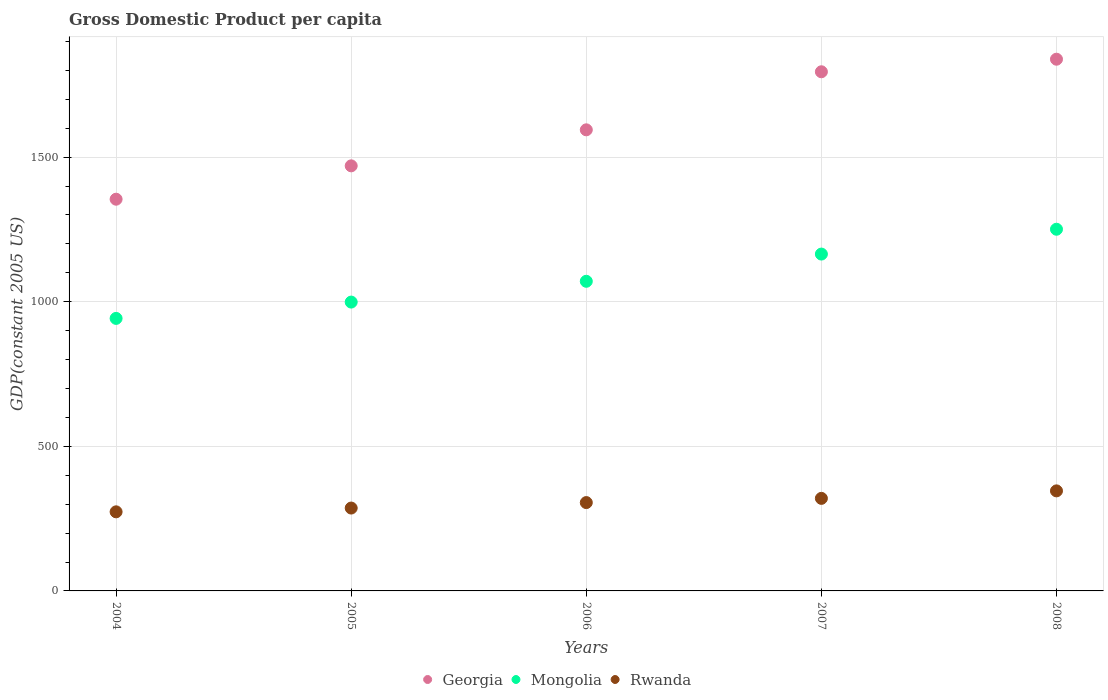Is the number of dotlines equal to the number of legend labels?
Give a very brief answer. Yes. What is the GDP per capita in Rwanda in 2004?
Your answer should be very brief. 273.48. Across all years, what is the maximum GDP per capita in Rwanda?
Provide a succinct answer. 345.97. Across all years, what is the minimum GDP per capita in Georgia?
Provide a short and direct response. 1354.56. What is the total GDP per capita in Georgia in the graph?
Your answer should be compact. 8052.87. What is the difference between the GDP per capita in Rwanda in 2004 and that in 2008?
Keep it short and to the point. -72.48. What is the difference between the GDP per capita in Mongolia in 2006 and the GDP per capita in Rwanda in 2004?
Offer a very short reply. 797.22. What is the average GDP per capita in Rwanda per year?
Your response must be concise. 306.31. In the year 2007, what is the difference between the GDP per capita in Georgia and GDP per capita in Mongolia?
Provide a short and direct response. 630.39. What is the ratio of the GDP per capita in Mongolia in 2007 to that in 2008?
Make the answer very short. 0.93. What is the difference between the highest and the second highest GDP per capita in Georgia?
Your answer should be very brief. 43.47. What is the difference between the highest and the lowest GDP per capita in Georgia?
Make the answer very short. 484.12. In how many years, is the GDP per capita in Rwanda greater than the average GDP per capita in Rwanda taken over all years?
Ensure brevity in your answer.  2. Is the GDP per capita in Mongolia strictly greater than the GDP per capita in Rwanda over the years?
Provide a succinct answer. Yes. Is the GDP per capita in Rwanda strictly less than the GDP per capita in Georgia over the years?
Ensure brevity in your answer.  Yes. How many years are there in the graph?
Your response must be concise. 5. What is the difference between two consecutive major ticks on the Y-axis?
Your answer should be compact. 500. Where does the legend appear in the graph?
Offer a very short reply. Bottom center. How many legend labels are there?
Offer a very short reply. 3. How are the legend labels stacked?
Your answer should be very brief. Horizontal. What is the title of the graph?
Ensure brevity in your answer.  Gross Domestic Product per capita. Does "Least developed countries" appear as one of the legend labels in the graph?
Your answer should be very brief. No. What is the label or title of the Y-axis?
Keep it short and to the point. GDP(constant 2005 US). What is the GDP(constant 2005 US) in Georgia in 2004?
Provide a short and direct response. 1354.56. What is the GDP(constant 2005 US) of Mongolia in 2004?
Provide a short and direct response. 942.4. What is the GDP(constant 2005 US) of Rwanda in 2004?
Ensure brevity in your answer.  273.48. What is the GDP(constant 2005 US) in Georgia in 2005?
Keep it short and to the point. 1469.93. What is the GDP(constant 2005 US) in Mongolia in 2005?
Offer a terse response. 998.82. What is the GDP(constant 2005 US) of Rwanda in 2005?
Make the answer very short. 286.57. What is the GDP(constant 2005 US) in Georgia in 2006?
Offer a very short reply. 1594.47. What is the GDP(constant 2005 US) of Mongolia in 2006?
Make the answer very short. 1070.71. What is the GDP(constant 2005 US) in Rwanda in 2006?
Your answer should be very brief. 305.48. What is the GDP(constant 2005 US) of Georgia in 2007?
Provide a short and direct response. 1795.21. What is the GDP(constant 2005 US) of Mongolia in 2007?
Your response must be concise. 1164.82. What is the GDP(constant 2005 US) in Rwanda in 2007?
Give a very brief answer. 320.06. What is the GDP(constant 2005 US) in Georgia in 2008?
Offer a very short reply. 1838.68. What is the GDP(constant 2005 US) in Mongolia in 2008?
Keep it short and to the point. 1250.7. What is the GDP(constant 2005 US) in Rwanda in 2008?
Give a very brief answer. 345.97. Across all years, what is the maximum GDP(constant 2005 US) of Georgia?
Provide a succinct answer. 1838.68. Across all years, what is the maximum GDP(constant 2005 US) of Mongolia?
Make the answer very short. 1250.7. Across all years, what is the maximum GDP(constant 2005 US) of Rwanda?
Offer a very short reply. 345.97. Across all years, what is the minimum GDP(constant 2005 US) of Georgia?
Offer a terse response. 1354.56. Across all years, what is the minimum GDP(constant 2005 US) in Mongolia?
Give a very brief answer. 942.4. Across all years, what is the minimum GDP(constant 2005 US) in Rwanda?
Ensure brevity in your answer.  273.48. What is the total GDP(constant 2005 US) in Georgia in the graph?
Your response must be concise. 8052.87. What is the total GDP(constant 2005 US) in Mongolia in the graph?
Ensure brevity in your answer.  5427.44. What is the total GDP(constant 2005 US) of Rwanda in the graph?
Your answer should be very brief. 1531.56. What is the difference between the GDP(constant 2005 US) of Georgia in 2004 and that in 2005?
Your response must be concise. -115.36. What is the difference between the GDP(constant 2005 US) of Mongolia in 2004 and that in 2005?
Provide a succinct answer. -56.43. What is the difference between the GDP(constant 2005 US) in Rwanda in 2004 and that in 2005?
Ensure brevity in your answer.  -13.08. What is the difference between the GDP(constant 2005 US) of Georgia in 2004 and that in 2006?
Make the answer very short. -239.91. What is the difference between the GDP(constant 2005 US) in Mongolia in 2004 and that in 2006?
Keep it short and to the point. -128.31. What is the difference between the GDP(constant 2005 US) in Rwanda in 2004 and that in 2006?
Give a very brief answer. -31.99. What is the difference between the GDP(constant 2005 US) in Georgia in 2004 and that in 2007?
Provide a short and direct response. -440.65. What is the difference between the GDP(constant 2005 US) of Mongolia in 2004 and that in 2007?
Offer a very short reply. -222.42. What is the difference between the GDP(constant 2005 US) of Rwanda in 2004 and that in 2007?
Provide a succinct answer. -46.58. What is the difference between the GDP(constant 2005 US) in Georgia in 2004 and that in 2008?
Your answer should be compact. -484.12. What is the difference between the GDP(constant 2005 US) of Mongolia in 2004 and that in 2008?
Ensure brevity in your answer.  -308.3. What is the difference between the GDP(constant 2005 US) in Rwanda in 2004 and that in 2008?
Your answer should be compact. -72.48. What is the difference between the GDP(constant 2005 US) of Georgia in 2005 and that in 2006?
Ensure brevity in your answer.  -124.55. What is the difference between the GDP(constant 2005 US) in Mongolia in 2005 and that in 2006?
Make the answer very short. -71.88. What is the difference between the GDP(constant 2005 US) of Rwanda in 2005 and that in 2006?
Offer a very short reply. -18.91. What is the difference between the GDP(constant 2005 US) of Georgia in 2005 and that in 2007?
Your answer should be very brief. -325.29. What is the difference between the GDP(constant 2005 US) in Mongolia in 2005 and that in 2007?
Make the answer very short. -166. What is the difference between the GDP(constant 2005 US) of Rwanda in 2005 and that in 2007?
Keep it short and to the point. -33.5. What is the difference between the GDP(constant 2005 US) in Georgia in 2005 and that in 2008?
Provide a short and direct response. -368.76. What is the difference between the GDP(constant 2005 US) in Mongolia in 2005 and that in 2008?
Your answer should be compact. -251.88. What is the difference between the GDP(constant 2005 US) of Rwanda in 2005 and that in 2008?
Keep it short and to the point. -59.4. What is the difference between the GDP(constant 2005 US) in Georgia in 2006 and that in 2007?
Offer a very short reply. -200.74. What is the difference between the GDP(constant 2005 US) in Mongolia in 2006 and that in 2007?
Provide a succinct answer. -94.11. What is the difference between the GDP(constant 2005 US) of Rwanda in 2006 and that in 2007?
Make the answer very short. -14.59. What is the difference between the GDP(constant 2005 US) in Georgia in 2006 and that in 2008?
Your answer should be very brief. -244.21. What is the difference between the GDP(constant 2005 US) in Mongolia in 2006 and that in 2008?
Your answer should be compact. -179.99. What is the difference between the GDP(constant 2005 US) in Rwanda in 2006 and that in 2008?
Ensure brevity in your answer.  -40.49. What is the difference between the GDP(constant 2005 US) in Georgia in 2007 and that in 2008?
Provide a succinct answer. -43.47. What is the difference between the GDP(constant 2005 US) in Mongolia in 2007 and that in 2008?
Offer a terse response. -85.88. What is the difference between the GDP(constant 2005 US) in Rwanda in 2007 and that in 2008?
Your answer should be very brief. -25.9. What is the difference between the GDP(constant 2005 US) in Georgia in 2004 and the GDP(constant 2005 US) in Mongolia in 2005?
Offer a very short reply. 355.74. What is the difference between the GDP(constant 2005 US) of Georgia in 2004 and the GDP(constant 2005 US) of Rwanda in 2005?
Give a very brief answer. 1068. What is the difference between the GDP(constant 2005 US) in Mongolia in 2004 and the GDP(constant 2005 US) in Rwanda in 2005?
Keep it short and to the point. 655.83. What is the difference between the GDP(constant 2005 US) in Georgia in 2004 and the GDP(constant 2005 US) in Mongolia in 2006?
Your answer should be very brief. 283.86. What is the difference between the GDP(constant 2005 US) in Georgia in 2004 and the GDP(constant 2005 US) in Rwanda in 2006?
Your response must be concise. 1049.09. What is the difference between the GDP(constant 2005 US) in Mongolia in 2004 and the GDP(constant 2005 US) in Rwanda in 2006?
Provide a succinct answer. 636.92. What is the difference between the GDP(constant 2005 US) in Georgia in 2004 and the GDP(constant 2005 US) in Mongolia in 2007?
Provide a succinct answer. 189.74. What is the difference between the GDP(constant 2005 US) of Georgia in 2004 and the GDP(constant 2005 US) of Rwanda in 2007?
Your response must be concise. 1034.5. What is the difference between the GDP(constant 2005 US) in Mongolia in 2004 and the GDP(constant 2005 US) in Rwanda in 2007?
Offer a very short reply. 622.33. What is the difference between the GDP(constant 2005 US) of Georgia in 2004 and the GDP(constant 2005 US) of Mongolia in 2008?
Keep it short and to the point. 103.87. What is the difference between the GDP(constant 2005 US) of Georgia in 2004 and the GDP(constant 2005 US) of Rwanda in 2008?
Ensure brevity in your answer.  1008.6. What is the difference between the GDP(constant 2005 US) in Mongolia in 2004 and the GDP(constant 2005 US) in Rwanda in 2008?
Offer a very short reply. 596.43. What is the difference between the GDP(constant 2005 US) in Georgia in 2005 and the GDP(constant 2005 US) in Mongolia in 2006?
Your answer should be very brief. 399.22. What is the difference between the GDP(constant 2005 US) in Georgia in 2005 and the GDP(constant 2005 US) in Rwanda in 2006?
Offer a terse response. 1164.45. What is the difference between the GDP(constant 2005 US) in Mongolia in 2005 and the GDP(constant 2005 US) in Rwanda in 2006?
Offer a very short reply. 693.35. What is the difference between the GDP(constant 2005 US) in Georgia in 2005 and the GDP(constant 2005 US) in Mongolia in 2007?
Your answer should be very brief. 305.11. What is the difference between the GDP(constant 2005 US) in Georgia in 2005 and the GDP(constant 2005 US) in Rwanda in 2007?
Your answer should be compact. 1149.86. What is the difference between the GDP(constant 2005 US) in Mongolia in 2005 and the GDP(constant 2005 US) in Rwanda in 2007?
Offer a very short reply. 678.76. What is the difference between the GDP(constant 2005 US) in Georgia in 2005 and the GDP(constant 2005 US) in Mongolia in 2008?
Ensure brevity in your answer.  219.23. What is the difference between the GDP(constant 2005 US) in Georgia in 2005 and the GDP(constant 2005 US) in Rwanda in 2008?
Make the answer very short. 1123.96. What is the difference between the GDP(constant 2005 US) in Mongolia in 2005 and the GDP(constant 2005 US) in Rwanda in 2008?
Your answer should be compact. 652.86. What is the difference between the GDP(constant 2005 US) of Georgia in 2006 and the GDP(constant 2005 US) of Mongolia in 2007?
Give a very brief answer. 429.65. What is the difference between the GDP(constant 2005 US) of Georgia in 2006 and the GDP(constant 2005 US) of Rwanda in 2007?
Give a very brief answer. 1274.41. What is the difference between the GDP(constant 2005 US) of Mongolia in 2006 and the GDP(constant 2005 US) of Rwanda in 2007?
Keep it short and to the point. 750.64. What is the difference between the GDP(constant 2005 US) in Georgia in 2006 and the GDP(constant 2005 US) in Mongolia in 2008?
Offer a terse response. 343.78. What is the difference between the GDP(constant 2005 US) of Georgia in 2006 and the GDP(constant 2005 US) of Rwanda in 2008?
Provide a succinct answer. 1248.51. What is the difference between the GDP(constant 2005 US) in Mongolia in 2006 and the GDP(constant 2005 US) in Rwanda in 2008?
Ensure brevity in your answer.  724.74. What is the difference between the GDP(constant 2005 US) in Georgia in 2007 and the GDP(constant 2005 US) in Mongolia in 2008?
Your response must be concise. 544.52. What is the difference between the GDP(constant 2005 US) of Georgia in 2007 and the GDP(constant 2005 US) of Rwanda in 2008?
Your answer should be compact. 1449.25. What is the difference between the GDP(constant 2005 US) of Mongolia in 2007 and the GDP(constant 2005 US) of Rwanda in 2008?
Give a very brief answer. 818.85. What is the average GDP(constant 2005 US) of Georgia per year?
Keep it short and to the point. 1610.57. What is the average GDP(constant 2005 US) in Mongolia per year?
Your answer should be very brief. 1085.49. What is the average GDP(constant 2005 US) in Rwanda per year?
Make the answer very short. 306.31. In the year 2004, what is the difference between the GDP(constant 2005 US) in Georgia and GDP(constant 2005 US) in Mongolia?
Your response must be concise. 412.17. In the year 2004, what is the difference between the GDP(constant 2005 US) in Georgia and GDP(constant 2005 US) in Rwanda?
Make the answer very short. 1081.08. In the year 2004, what is the difference between the GDP(constant 2005 US) of Mongolia and GDP(constant 2005 US) of Rwanda?
Give a very brief answer. 668.91. In the year 2005, what is the difference between the GDP(constant 2005 US) in Georgia and GDP(constant 2005 US) in Mongolia?
Your answer should be compact. 471.11. In the year 2005, what is the difference between the GDP(constant 2005 US) of Georgia and GDP(constant 2005 US) of Rwanda?
Your answer should be very brief. 1183.36. In the year 2005, what is the difference between the GDP(constant 2005 US) of Mongolia and GDP(constant 2005 US) of Rwanda?
Your response must be concise. 712.25. In the year 2006, what is the difference between the GDP(constant 2005 US) of Georgia and GDP(constant 2005 US) of Mongolia?
Ensure brevity in your answer.  523.77. In the year 2006, what is the difference between the GDP(constant 2005 US) in Georgia and GDP(constant 2005 US) in Rwanda?
Provide a succinct answer. 1289. In the year 2006, what is the difference between the GDP(constant 2005 US) of Mongolia and GDP(constant 2005 US) of Rwanda?
Provide a succinct answer. 765.23. In the year 2007, what is the difference between the GDP(constant 2005 US) of Georgia and GDP(constant 2005 US) of Mongolia?
Offer a terse response. 630.39. In the year 2007, what is the difference between the GDP(constant 2005 US) in Georgia and GDP(constant 2005 US) in Rwanda?
Your answer should be compact. 1475.15. In the year 2007, what is the difference between the GDP(constant 2005 US) of Mongolia and GDP(constant 2005 US) of Rwanda?
Keep it short and to the point. 844.76. In the year 2008, what is the difference between the GDP(constant 2005 US) of Georgia and GDP(constant 2005 US) of Mongolia?
Keep it short and to the point. 587.99. In the year 2008, what is the difference between the GDP(constant 2005 US) in Georgia and GDP(constant 2005 US) in Rwanda?
Offer a terse response. 1492.72. In the year 2008, what is the difference between the GDP(constant 2005 US) of Mongolia and GDP(constant 2005 US) of Rwanda?
Your response must be concise. 904.73. What is the ratio of the GDP(constant 2005 US) of Georgia in 2004 to that in 2005?
Offer a very short reply. 0.92. What is the ratio of the GDP(constant 2005 US) in Mongolia in 2004 to that in 2005?
Offer a very short reply. 0.94. What is the ratio of the GDP(constant 2005 US) of Rwanda in 2004 to that in 2005?
Give a very brief answer. 0.95. What is the ratio of the GDP(constant 2005 US) of Georgia in 2004 to that in 2006?
Keep it short and to the point. 0.85. What is the ratio of the GDP(constant 2005 US) in Mongolia in 2004 to that in 2006?
Provide a short and direct response. 0.88. What is the ratio of the GDP(constant 2005 US) in Rwanda in 2004 to that in 2006?
Provide a succinct answer. 0.9. What is the ratio of the GDP(constant 2005 US) of Georgia in 2004 to that in 2007?
Your response must be concise. 0.75. What is the ratio of the GDP(constant 2005 US) of Mongolia in 2004 to that in 2007?
Offer a terse response. 0.81. What is the ratio of the GDP(constant 2005 US) of Rwanda in 2004 to that in 2007?
Offer a terse response. 0.85. What is the ratio of the GDP(constant 2005 US) of Georgia in 2004 to that in 2008?
Offer a terse response. 0.74. What is the ratio of the GDP(constant 2005 US) of Mongolia in 2004 to that in 2008?
Make the answer very short. 0.75. What is the ratio of the GDP(constant 2005 US) of Rwanda in 2004 to that in 2008?
Provide a succinct answer. 0.79. What is the ratio of the GDP(constant 2005 US) in Georgia in 2005 to that in 2006?
Your answer should be very brief. 0.92. What is the ratio of the GDP(constant 2005 US) of Mongolia in 2005 to that in 2006?
Make the answer very short. 0.93. What is the ratio of the GDP(constant 2005 US) of Rwanda in 2005 to that in 2006?
Provide a short and direct response. 0.94. What is the ratio of the GDP(constant 2005 US) in Georgia in 2005 to that in 2007?
Provide a short and direct response. 0.82. What is the ratio of the GDP(constant 2005 US) in Mongolia in 2005 to that in 2007?
Your answer should be very brief. 0.86. What is the ratio of the GDP(constant 2005 US) of Rwanda in 2005 to that in 2007?
Give a very brief answer. 0.9. What is the ratio of the GDP(constant 2005 US) in Georgia in 2005 to that in 2008?
Offer a very short reply. 0.8. What is the ratio of the GDP(constant 2005 US) of Mongolia in 2005 to that in 2008?
Provide a short and direct response. 0.8. What is the ratio of the GDP(constant 2005 US) in Rwanda in 2005 to that in 2008?
Ensure brevity in your answer.  0.83. What is the ratio of the GDP(constant 2005 US) of Georgia in 2006 to that in 2007?
Your response must be concise. 0.89. What is the ratio of the GDP(constant 2005 US) in Mongolia in 2006 to that in 2007?
Provide a short and direct response. 0.92. What is the ratio of the GDP(constant 2005 US) in Rwanda in 2006 to that in 2007?
Keep it short and to the point. 0.95. What is the ratio of the GDP(constant 2005 US) of Georgia in 2006 to that in 2008?
Make the answer very short. 0.87. What is the ratio of the GDP(constant 2005 US) in Mongolia in 2006 to that in 2008?
Your answer should be compact. 0.86. What is the ratio of the GDP(constant 2005 US) in Rwanda in 2006 to that in 2008?
Your answer should be very brief. 0.88. What is the ratio of the GDP(constant 2005 US) in Georgia in 2007 to that in 2008?
Make the answer very short. 0.98. What is the ratio of the GDP(constant 2005 US) of Mongolia in 2007 to that in 2008?
Give a very brief answer. 0.93. What is the ratio of the GDP(constant 2005 US) in Rwanda in 2007 to that in 2008?
Make the answer very short. 0.93. What is the difference between the highest and the second highest GDP(constant 2005 US) of Georgia?
Your response must be concise. 43.47. What is the difference between the highest and the second highest GDP(constant 2005 US) in Mongolia?
Your answer should be compact. 85.88. What is the difference between the highest and the second highest GDP(constant 2005 US) of Rwanda?
Ensure brevity in your answer.  25.9. What is the difference between the highest and the lowest GDP(constant 2005 US) in Georgia?
Offer a terse response. 484.12. What is the difference between the highest and the lowest GDP(constant 2005 US) in Mongolia?
Offer a terse response. 308.3. What is the difference between the highest and the lowest GDP(constant 2005 US) of Rwanda?
Give a very brief answer. 72.48. 